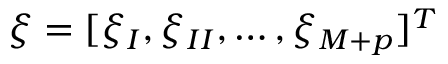<formula> <loc_0><loc_0><loc_500><loc_500>\xi = [ \xi _ { I } , \xi _ { I I } , \dots , \xi _ { M + p } ] ^ { T }</formula> 